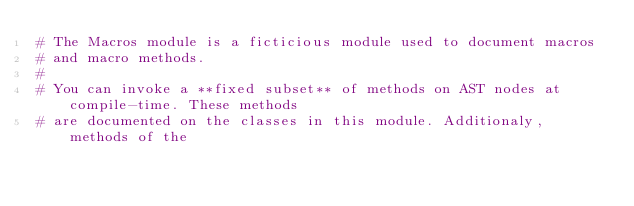<code> <loc_0><loc_0><loc_500><loc_500><_Crystal_># The Macros module is a ficticious module used to document macros
# and macro methods.
#
# You can invoke a **fixed subset** of methods on AST nodes at compile-time. These methods
# are documented on the classes in this module. Additionaly, methods of the</code> 